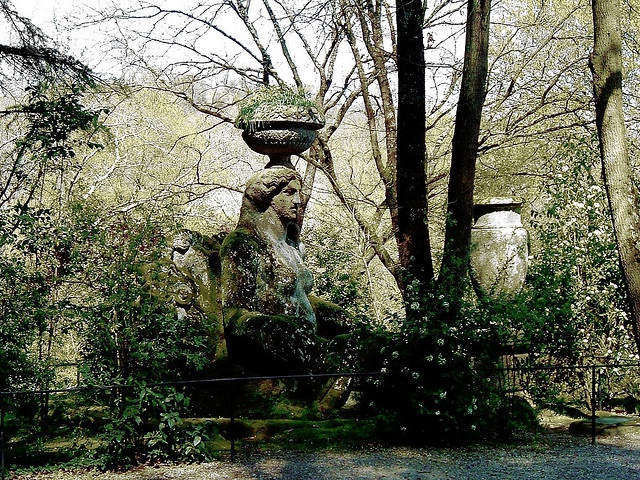Describe the objects in this image and their specific colors. I can see a potted plant in gray, black, ivory, and darkgray tones in this image. 